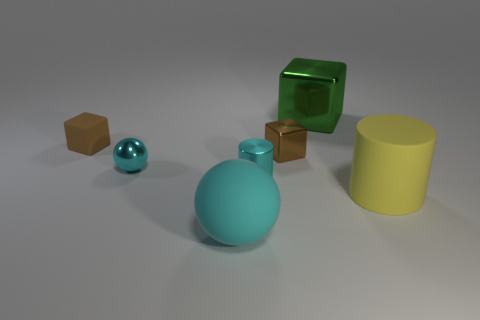Which objects in the image have a reflective surface? The large yellow cylinder, the cyan sphere, and the green cube all have reflective surfaces that show light bouncing off them, giving them a shiny appearance. 